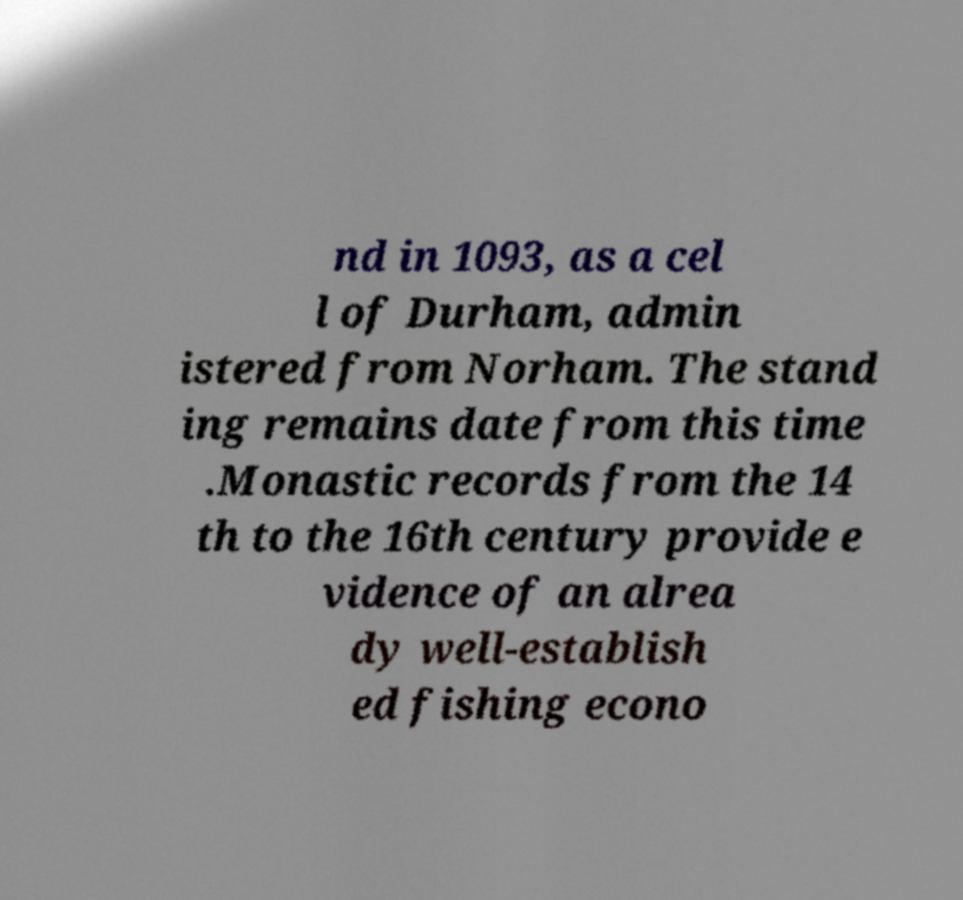Could you extract and type out the text from this image? nd in 1093, as a cel l of Durham, admin istered from Norham. The stand ing remains date from this time .Monastic records from the 14 th to the 16th century provide e vidence of an alrea dy well-establish ed fishing econo 